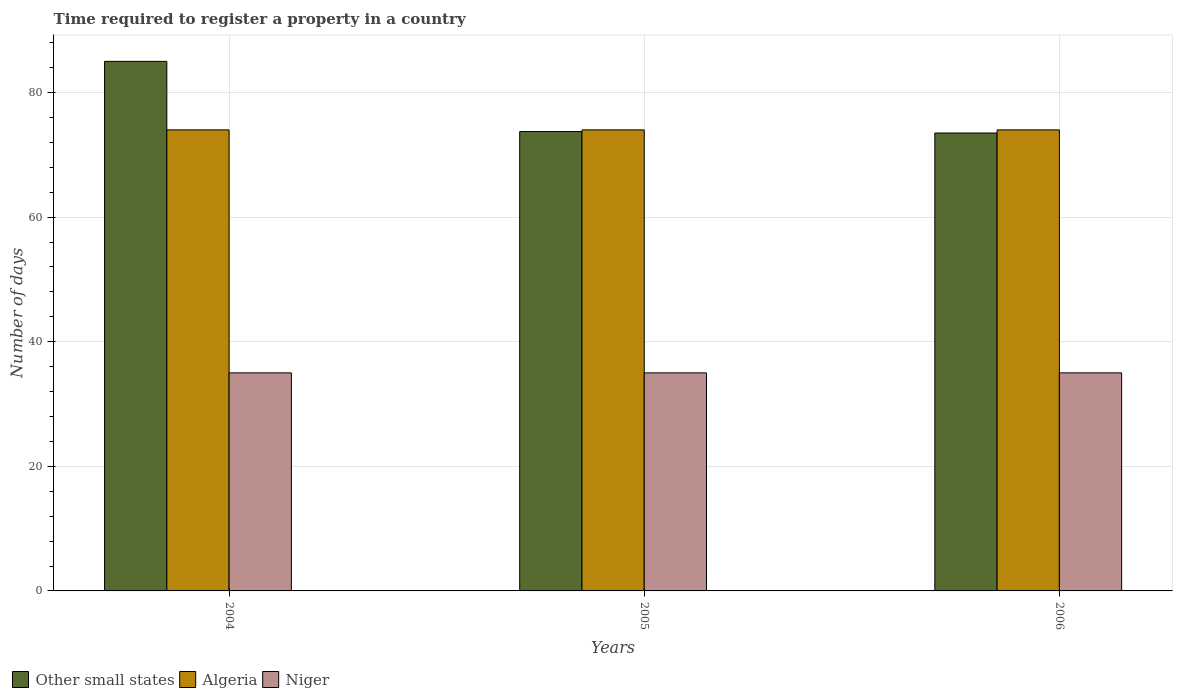How many different coloured bars are there?
Ensure brevity in your answer.  3. How many groups of bars are there?
Your response must be concise. 3. Are the number of bars per tick equal to the number of legend labels?
Your answer should be very brief. Yes. How many bars are there on the 3rd tick from the left?
Offer a terse response. 3. In how many cases, is the number of bars for a given year not equal to the number of legend labels?
Keep it short and to the point. 0. What is the number of days required to register a property in Algeria in 2005?
Provide a short and direct response. 74. Across all years, what is the maximum number of days required to register a property in Other small states?
Keep it short and to the point. 85. Across all years, what is the minimum number of days required to register a property in Algeria?
Offer a very short reply. 74. In which year was the number of days required to register a property in Other small states minimum?
Offer a terse response. 2006. What is the total number of days required to register a property in Niger in the graph?
Your answer should be very brief. 105. What is the difference between the number of days required to register a property in Other small states in 2004 and that in 2006?
Your answer should be compact. 11.5. What is the difference between the number of days required to register a property in Algeria in 2005 and the number of days required to register a property in Niger in 2004?
Your response must be concise. 39. What is the ratio of the number of days required to register a property in Other small states in 2005 to that in 2006?
Provide a short and direct response. 1. Is the difference between the number of days required to register a property in Other small states in 2004 and 2006 greater than the difference between the number of days required to register a property in Algeria in 2004 and 2006?
Your response must be concise. Yes. What is the difference between the highest and the second highest number of days required to register a property in Algeria?
Provide a short and direct response. 0. In how many years, is the number of days required to register a property in Other small states greater than the average number of days required to register a property in Other small states taken over all years?
Your answer should be very brief. 1. What does the 2nd bar from the left in 2004 represents?
Provide a short and direct response. Algeria. What does the 1st bar from the right in 2004 represents?
Offer a very short reply. Niger. Are the values on the major ticks of Y-axis written in scientific E-notation?
Your answer should be compact. No. Does the graph contain any zero values?
Your response must be concise. No. How are the legend labels stacked?
Make the answer very short. Horizontal. What is the title of the graph?
Provide a succinct answer. Time required to register a property in a country. Does "Georgia" appear as one of the legend labels in the graph?
Offer a very short reply. No. What is the label or title of the Y-axis?
Offer a very short reply. Number of days. What is the Number of days in Other small states in 2004?
Offer a very short reply. 85. What is the Number of days of Niger in 2004?
Ensure brevity in your answer.  35. What is the Number of days in Other small states in 2005?
Your response must be concise. 73.73. What is the Number of days in Algeria in 2005?
Your answer should be very brief. 74. What is the Number of days in Niger in 2005?
Offer a very short reply. 35. What is the Number of days of Other small states in 2006?
Make the answer very short. 73.5. What is the Number of days of Algeria in 2006?
Your answer should be very brief. 74. Across all years, what is the maximum Number of days of Other small states?
Your answer should be compact. 85. Across all years, what is the maximum Number of days in Algeria?
Ensure brevity in your answer.  74. Across all years, what is the maximum Number of days in Niger?
Your response must be concise. 35. Across all years, what is the minimum Number of days of Other small states?
Make the answer very short. 73.5. What is the total Number of days in Other small states in the graph?
Offer a terse response. 232.23. What is the total Number of days of Algeria in the graph?
Give a very brief answer. 222. What is the total Number of days of Niger in the graph?
Ensure brevity in your answer.  105. What is the difference between the Number of days in Other small states in 2004 and that in 2005?
Your answer should be very brief. 11.27. What is the difference between the Number of days of Niger in 2004 and that in 2005?
Keep it short and to the point. 0. What is the difference between the Number of days of Algeria in 2004 and that in 2006?
Provide a succinct answer. 0. What is the difference between the Number of days of Other small states in 2005 and that in 2006?
Provide a succinct answer. 0.23. What is the difference between the Number of days in Algeria in 2005 and that in 2006?
Give a very brief answer. 0. What is the difference between the Number of days of Other small states in 2004 and the Number of days of Algeria in 2005?
Offer a terse response. 11. What is the difference between the Number of days of Other small states in 2004 and the Number of days of Algeria in 2006?
Provide a short and direct response. 11. What is the difference between the Number of days in Other small states in 2005 and the Number of days in Algeria in 2006?
Give a very brief answer. -0.27. What is the difference between the Number of days in Other small states in 2005 and the Number of days in Niger in 2006?
Offer a very short reply. 38.73. What is the difference between the Number of days in Algeria in 2005 and the Number of days in Niger in 2006?
Offer a terse response. 39. What is the average Number of days in Other small states per year?
Ensure brevity in your answer.  77.41. What is the average Number of days of Algeria per year?
Your answer should be very brief. 74. What is the average Number of days in Niger per year?
Ensure brevity in your answer.  35. In the year 2004, what is the difference between the Number of days of Other small states and Number of days of Algeria?
Offer a very short reply. 11. In the year 2004, what is the difference between the Number of days of Other small states and Number of days of Niger?
Make the answer very short. 50. In the year 2004, what is the difference between the Number of days in Algeria and Number of days in Niger?
Ensure brevity in your answer.  39. In the year 2005, what is the difference between the Number of days in Other small states and Number of days in Algeria?
Ensure brevity in your answer.  -0.27. In the year 2005, what is the difference between the Number of days in Other small states and Number of days in Niger?
Provide a succinct answer. 38.73. In the year 2005, what is the difference between the Number of days of Algeria and Number of days of Niger?
Make the answer very short. 39. In the year 2006, what is the difference between the Number of days in Other small states and Number of days in Niger?
Your answer should be compact. 38.5. In the year 2006, what is the difference between the Number of days of Algeria and Number of days of Niger?
Offer a very short reply. 39. What is the ratio of the Number of days in Other small states in 2004 to that in 2005?
Your response must be concise. 1.15. What is the ratio of the Number of days of Algeria in 2004 to that in 2005?
Ensure brevity in your answer.  1. What is the ratio of the Number of days in Niger in 2004 to that in 2005?
Keep it short and to the point. 1. What is the ratio of the Number of days in Other small states in 2004 to that in 2006?
Offer a very short reply. 1.16. What is the ratio of the Number of days in Other small states in 2005 to that in 2006?
Your answer should be compact. 1. What is the ratio of the Number of days in Algeria in 2005 to that in 2006?
Give a very brief answer. 1. What is the ratio of the Number of days of Niger in 2005 to that in 2006?
Provide a short and direct response. 1. What is the difference between the highest and the second highest Number of days of Other small states?
Provide a succinct answer. 11.27. What is the difference between the highest and the second highest Number of days of Algeria?
Your answer should be compact. 0. What is the difference between the highest and the lowest Number of days of Other small states?
Provide a succinct answer. 11.5. What is the difference between the highest and the lowest Number of days of Algeria?
Keep it short and to the point. 0. 